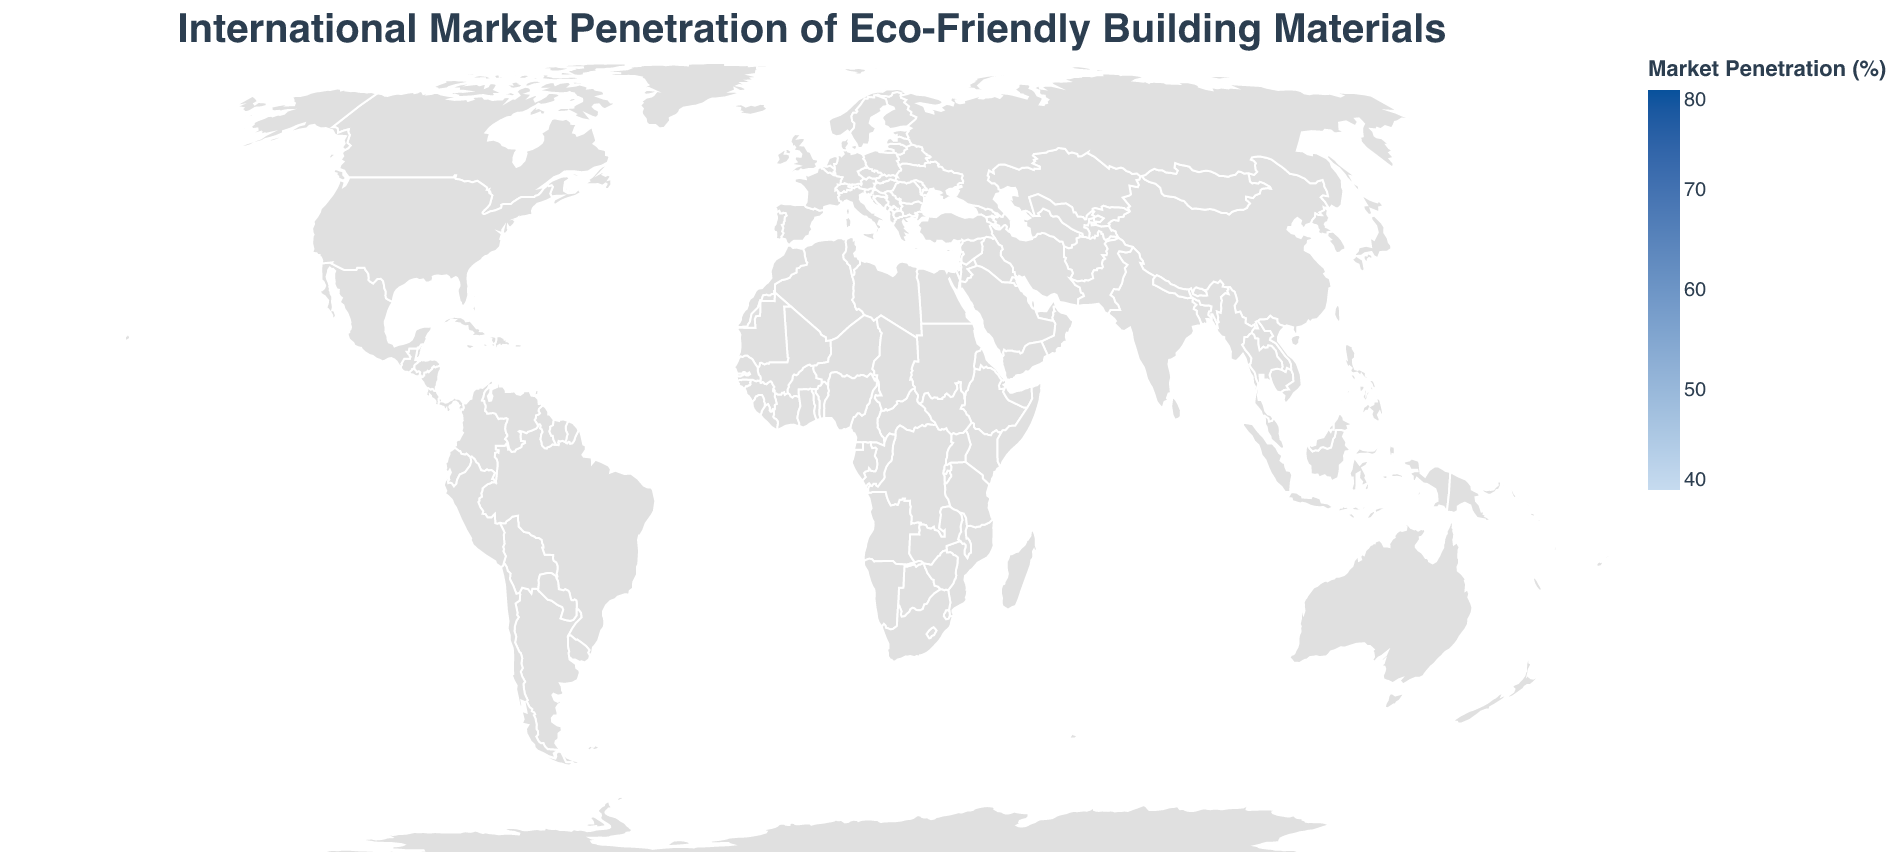Which country has the highest market penetration of eco-friendly building materials? The highest market penetration in the figure is represented by the darkest shade of blue. Observing the chart, Sweden has the highest market penetration rate at 75%.
Answer: Sweden Which country has the lowest market penetration of eco-friendly building materials? The lowest market penetration in the figure is represented by the lightest shade of blue. Observing the chart, the United States has the lowest market penetration rate at 42%.
Answer: United States What is the market penetration rate of eco-friendly building materials in Germany? Identify Germany on the map and check the associated market penetration value, which is 68%.
Answer: 68% How does the market penetration rate in the United Kingdom compare to that in the Netherlands? The market penetration rate for the United Kingdom is 59%, while the Netherlands has a rate of 71%. Therefore, the Netherlands has a higher market penetration rate than the United Kingdom.
Answer: 71% in the Netherlands and 59% in the United Kingdom What is the average market penetration rate of eco-friendly building materials for the countries listed? To calculate the average:
1. Add up all the market penetration rates: 42 + 68 + 55 + 49 + 75 + 71 + 51 + 59 + 63 + 72 + 47 + 44 + 70 + 69 + 66 + 61 + 58 + 53 + 50 + 46 = 1123
2. Divide by the number of countries, which is 20.
Average = 1123 / 20 = 56.15
Answer: 56.15 Which countries have a market penetration rate greater than 60%? Look for countries with a market penetration rate higher than 60%. These countries are Germany (68%), Sweden (75%), Netherlands (71%), United Kingdom (59%), France (63%), Denmark (72%), Norway (70%), Finland (69%), Switzerland (66%), Austria (61%).
Answer: Germany, Sweden, Netherlands, France, Denmark, Norway, Finland, Switzerland, Austria How many countries have a market penetration rate between 50% and 60%? Count the countries with market penetration rates within this range: Japan (55%), Canada (51%), United Kingdom (59%), Belgium (58%), New Zealand (53%), Singapore (50%).
Answer: 6 What is the total market penetration rate for the Scandinavian countries (Sweden, Denmark, Norway, Finland)? Add the market penetration rates for these countries: Sweden (75%) + Denmark (72%) + Norway (70%) + Finland (69%) = 286
Answer: 286 Which two countries have the closest market penetration rates? Compare market penetration rates to find the smallest difference between two values. Norway (70%) and Netherlands (71%) have the smallest difference of 1%.
Answer: Norway and Netherlands Which region has the highest clustering of countries with a high market penetration rate? The region consisting of Scandinavian and some nearby countries (Sweden, Denmark, Norway, Finland, and Netherlands) shows high clustering of high market penetration rates (above 60%).
Answer: Scandinavian region and nearby countries 